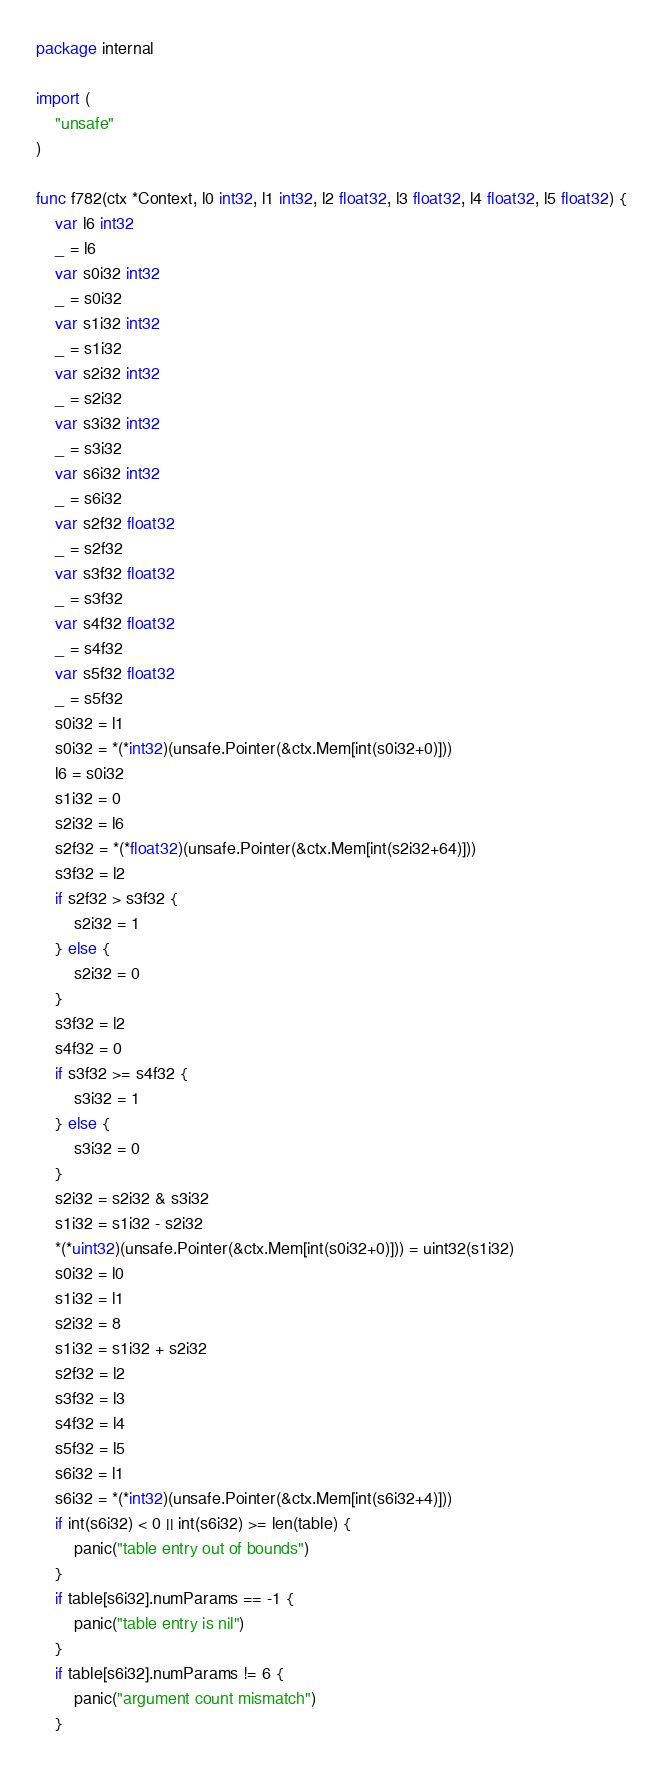Convert code to text. <code><loc_0><loc_0><loc_500><loc_500><_Go_>package internal

import (
	"unsafe"
)

func f782(ctx *Context, l0 int32, l1 int32, l2 float32, l3 float32, l4 float32, l5 float32) {
	var l6 int32
	_ = l6
	var s0i32 int32
	_ = s0i32
	var s1i32 int32
	_ = s1i32
	var s2i32 int32
	_ = s2i32
	var s3i32 int32
	_ = s3i32
	var s6i32 int32
	_ = s6i32
	var s2f32 float32
	_ = s2f32
	var s3f32 float32
	_ = s3f32
	var s4f32 float32
	_ = s4f32
	var s5f32 float32
	_ = s5f32
	s0i32 = l1
	s0i32 = *(*int32)(unsafe.Pointer(&ctx.Mem[int(s0i32+0)]))
	l6 = s0i32
	s1i32 = 0
	s2i32 = l6
	s2f32 = *(*float32)(unsafe.Pointer(&ctx.Mem[int(s2i32+64)]))
	s3f32 = l2
	if s2f32 > s3f32 {
		s2i32 = 1
	} else {
		s2i32 = 0
	}
	s3f32 = l2
	s4f32 = 0
	if s3f32 >= s4f32 {
		s3i32 = 1
	} else {
		s3i32 = 0
	}
	s2i32 = s2i32 & s3i32
	s1i32 = s1i32 - s2i32
	*(*uint32)(unsafe.Pointer(&ctx.Mem[int(s0i32+0)])) = uint32(s1i32)
	s0i32 = l0
	s1i32 = l1
	s2i32 = 8
	s1i32 = s1i32 + s2i32
	s2f32 = l2
	s3f32 = l3
	s4f32 = l4
	s5f32 = l5
	s6i32 = l1
	s6i32 = *(*int32)(unsafe.Pointer(&ctx.Mem[int(s6i32+4)]))
	if int(s6i32) < 0 || int(s6i32) >= len(table) {
		panic("table entry out of bounds")
	}
	if table[s6i32].numParams == -1 {
		panic("table entry is nil")
	}
	if table[s6i32].numParams != 6 {
		panic("argument count mismatch")
	}</code> 